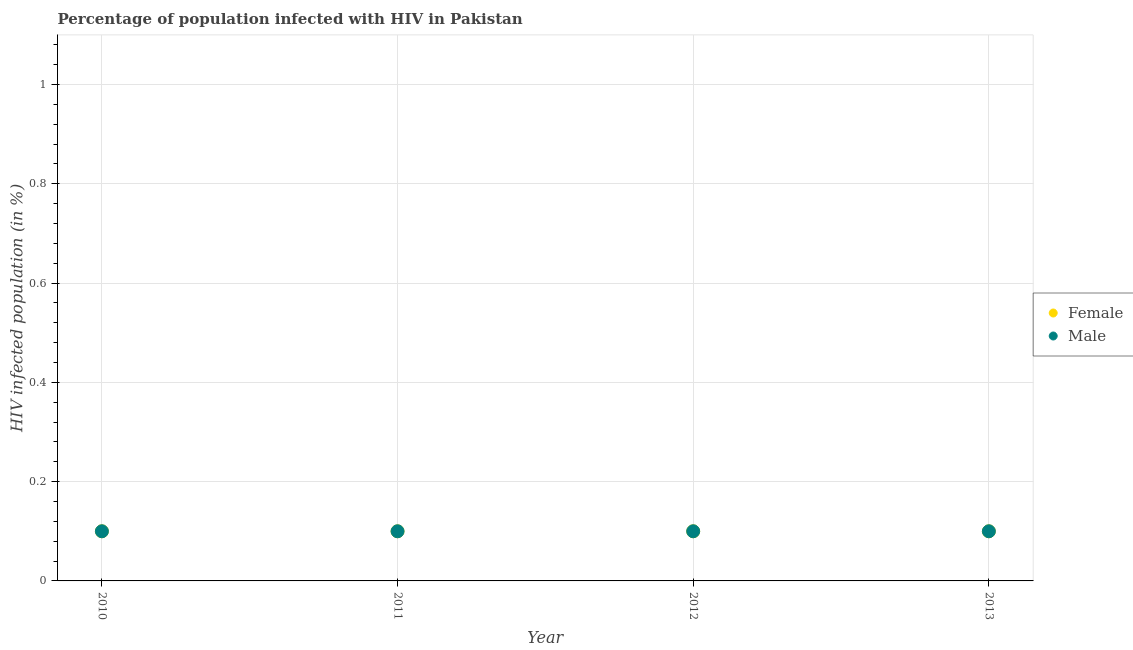How many different coloured dotlines are there?
Ensure brevity in your answer.  2. What is the percentage of females who are infected with hiv in 2010?
Keep it short and to the point. 0.1. Across all years, what is the minimum percentage of males who are infected with hiv?
Keep it short and to the point. 0.1. In which year was the percentage of males who are infected with hiv maximum?
Give a very brief answer. 2010. What is the total percentage of females who are infected with hiv in the graph?
Give a very brief answer. 0.4. In how many years, is the percentage of males who are infected with hiv greater than 0.6400000000000001 %?
Provide a succinct answer. 0. What is the ratio of the percentage of females who are infected with hiv in 2012 to that in 2013?
Ensure brevity in your answer.  1. Is the percentage of females who are infected with hiv in 2010 less than that in 2012?
Your answer should be compact. No. Is the difference between the percentage of females who are infected with hiv in 2011 and 2013 greater than the difference between the percentage of males who are infected with hiv in 2011 and 2013?
Your answer should be compact. No. Does the percentage of males who are infected with hiv monotonically increase over the years?
Provide a succinct answer. No. Is the percentage of males who are infected with hiv strictly less than the percentage of females who are infected with hiv over the years?
Your answer should be very brief. No. How many dotlines are there?
Your response must be concise. 2. What is the difference between two consecutive major ticks on the Y-axis?
Provide a succinct answer. 0.2. Does the graph contain any zero values?
Give a very brief answer. No. How many legend labels are there?
Give a very brief answer. 2. How are the legend labels stacked?
Offer a terse response. Vertical. What is the title of the graph?
Your response must be concise. Percentage of population infected with HIV in Pakistan. What is the label or title of the Y-axis?
Offer a terse response. HIV infected population (in %). What is the HIV infected population (in %) of Male in 2010?
Your answer should be very brief. 0.1. What is the HIV infected population (in %) of Female in 2011?
Keep it short and to the point. 0.1. What is the HIV infected population (in %) of Male in 2011?
Offer a terse response. 0.1. What is the HIV infected population (in %) of Female in 2012?
Ensure brevity in your answer.  0.1. What is the HIV infected population (in %) in Female in 2013?
Provide a short and direct response. 0.1. What is the HIV infected population (in %) in Male in 2013?
Provide a short and direct response. 0.1. Across all years, what is the minimum HIV infected population (in %) of Male?
Offer a terse response. 0.1. What is the total HIV infected population (in %) of Male in the graph?
Keep it short and to the point. 0.4. What is the difference between the HIV infected population (in %) of Male in 2010 and that in 2011?
Keep it short and to the point. 0. What is the difference between the HIV infected population (in %) in Male in 2010 and that in 2013?
Your answer should be compact. 0. What is the difference between the HIV infected population (in %) of Male in 2011 and that in 2012?
Make the answer very short. 0. What is the difference between the HIV infected population (in %) in Male in 2011 and that in 2013?
Your answer should be very brief. 0. What is the difference between the HIV infected population (in %) of Male in 2012 and that in 2013?
Give a very brief answer. 0. What is the difference between the HIV infected population (in %) of Female in 2010 and the HIV infected population (in %) of Male in 2012?
Offer a very short reply. 0. What is the average HIV infected population (in %) of Female per year?
Provide a succinct answer. 0.1. What is the average HIV infected population (in %) of Male per year?
Ensure brevity in your answer.  0.1. In the year 2011, what is the difference between the HIV infected population (in %) in Female and HIV infected population (in %) in Male?
Make the answer very short. 0. In the year 2013, what is the difference between the HIV infected population (in %) of Female and HIV infected population (in %) of Male?
Give a very brief answer. 0. What is the ratio of the HIV infected population (in %) in Male in 2010 to that in 2011?
Offer a terse response. 1. What is the ratio of the HIV infected population (in %) in Female in 2010 to that in 2012?
Ensure brevity in your answer.  1. What is the ratio of the HIV infected population (in %) in Male in 2010 to that in 2012?
Your answer should be very brief. 1. What is the ratio of the HIV infected population (in %) of Female in 2012 to that in 2013?
Provide a succinct answer. 1. What is the difference between the highest and the lowest HIV infected population (in %) of Female?
Your answer should be compact. 0. What is the difference between the highest and the lowest HIV infected population (in %) of Male?
Keep it short and to the point. 0. 